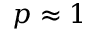Convert formula to latex. <formula><loc_0><loc_0><loc_500><loc_500>p \approx 1</formula> 